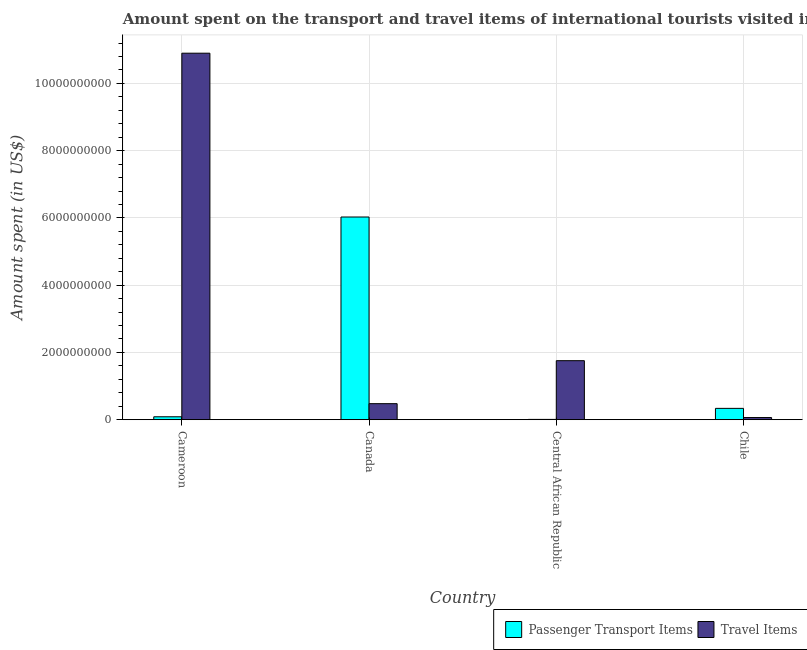How many different coloured bars are there?
Provide a short and direct response. 2. Are the number of bars per tick equal to the number of legend labels?
Provide a succinct answer. Yes. Are the number of bars on each tick of the X-axis equal?
Your answer should be compact. Yes. How many bars are there on the 3rd tick from the right?
Make the answer very short. 2. What is the label of the 1st group of bars from the left?
Keep it short and to the point. Cameroon. In how many cases, is the number of bars for a given country not equal to the number of legend labels?
Provide a short and direct response. 0. What is the amount spent in travel items in Canada?
Your response must be concise. 4.77e+08. Across all countries, what is the maximum amount spent in travel items?
Your answer should be very brief. 1.09e+1. Across all countries, what is the minimum amount spent on passenger transport items?
Your response must be concise. 9.00e+06. In which country was the amount spent on passenger transport items minimum?
Provide a short and direct response. Central African Republic. What is the total amount spent on passenger transport items in the graph?
Ensure brevity in your answer.  6.46e+09. What is the difference between the amount spent in travel items in Cameroon and that in Central African Republic?
Provide a succinct answer. 9.14e+09. What is the difference between the amount spent on passenger transport items in Canada and the amount spent in travel items in Cameroon?
Offer a very short reply. -4.87e+09. What is the average amount spent on passenger transport items per country?
Your response must be concise. 1.62e+09. What is the difference between the amount spent on passenger transport items and amount spent in travel items in Central African Republic?
Offer a terse response. -1.75e+09. In how many countries, is the amount spent in travel items greater than 7200000000 US$?
Make the answer very short. 1. What is the ratio of the amount spent in travel items in Canada to that in Chile?
Your answer should be very brief. 7.45. Is the amount spent on passenger transport items in Cameroon less than that in Chile?
Offer a very short reply. Yes. Is the difference between the amount spent in travel items in Cameroon and Central African Republic greater than the difference between the amount spent on passenger transport items in Cameroon and Central African Republic?
Ensure brevity in your answer.  Yes. What is the difference between the highest and the second highest amount spent on passenger transport items?
Make the answer very short. 5.69e+09. What is the difference between the highest and the lowest amount spent on passenger transport items?
Ensure brevity in your answer.  6.02e+09. Is the sum of the amount spent in travel items in Cameroon and Chile greater than the maximum amount spent on passenger transport items across all countries?
Keep it short and to the point. Yes. What does the 2nd bar from the left in Central African Republic represents?
Provide a short and direct response. Travel Items. What does the 2nd bar from the right in Cameroon represents?
Your answer should be very brief. Passenger Transport Items. What is the difference between two consecutive major ticks on the Y-axis?
Provide a succinct answer. 2.00e+09. Are the values on the major ticks of Y-axis written in scientific E-notation?
Provide a succinct answer. No. Does the graph contain grids?
Ensure brevity in your answer.  Yes. Where does the legend appear in the graph?
Offer a terse response. Bottom right. How many legend labels are there?
Your answer should be compact. 2. How are the legend labels stacked?
Give a very brief answer. Horizontal. What is the title of the graph?
Your answer should be very brief. Amount spent on the transport and travel items of international tourists visited in 2009. What is the label or title of the X-axis?
Provide a short and direct response. Country. What is the label or title of the Y-axis?
Give a very brief answer. Amount spent (in US$). What is the Amount spent (in US$) of Passenger Transport Items in Cameroon?
Give a very brief answer. 8.70e+07. What is the Amount spent (in US$) of Travel Items in Cameroon?
Keep it short and to the point. 1.09e+1. What is the Amount spent (in US$) in Passenger Transport Items in Canada?
Provide a succinct answer. 6.03e+09. What is the Amount spent (in US$) in Travel Items in Canada?
Keep it short and to the point. 4.77e+08. What is the Amount spent (in US$) of Passenger Transport Items in Central African Republic?
Keep it short and to the point. 9.00e+06. What is the Amount spent (in US$) of Travel Items in Central African Republic?
Give a very brief answer. 1.76e+09. What is the Amount spent (in US$) of Passenger Transport Items in Chile?
Ensure brevity in your answer.  3.37e+08. What is the Amount spent (in US$) of Travel Items in Chile?
Your response must be concise. 6.40e+07. Across all countries, what is the maximum Amount spent (in US$) of Passenger Transport Items?
Provide a succinct answer. 6.03e+09. Across all countries, what is the maximum Amount spent (in US$) in Travel Items?
Your answer should be compact. 1.09e+1. Across all countries, what is the minimum Amount spent (in US$) in Passenger Transport Items?
Offer a very short reply. 9.00e+06. Across all countries, what is the minimum Amount spent (in US$) in Travel Items?
Your answer should be compact. 6.40e+07. What is the total Amount spent (in US$) in Passenger Transport Items in the graph?
Provide a succinct answer. 6.46e+09. What is the total Amount spent (in US$) of Travel Items in the graph?
Your answer should be very brief. 1.32e+1. What is the difference between the Amount spent (in US$) in Passenger Transport Items in Cameroon and that in Canada?
Keep it short and to the point. -5.94e+09. What is the difference between the Amount spent (in US$) of Travel Items in Cameroon and that in Canada?
Offer a terse response. 1.04e+1. What is the difference between the Amount spent (in US$) in Passenger Transport Items in Cameroon and that in Central African Republic?
Ensure brevity in your answer.  7.80e+07. What is the difference between the Amount spent (in US$) in Travel Items in Cameroon and that in Central African Republic?
Ensure brevity in your answer.  9.14e+09. What is the difference between the Amount spent (in US$) of Passenger Transport Items in Cameroon and that in Chile?
Ensure brevity in your answer.  -2.50e+08. What is the difference between the Amount spent (in US$) in Travel Items in Cameroon and that in Chile?
Offer a very short reply. 1.08e+1. What is the difference between the Amount spent (in US$) in Passenger Transport Items in Canada and that in Central African Republic?
Offer a very short reply. 6.02e+09. What is the difference between the Amount spent (in US$) of Travel Items in Canada and that in Central African Republic?
Offer a very short reply. -1.28e+09. What is the difference between the Amount spent (in US$) in Passenger Transport Items in Canada and that in Chile?
Offer a very short reply. 5.69e+09. What is the difference between the Amount spent (in US$) of Travel Items in Canada and that in Chile?
Ensure brevity in your answer.  4.13e+08. What is the difference between the Amount spent (in US$) of Passenger Transport Items in Central African Republic and that in Chile?
Your answer should be compact. -3.28e+08. What is the difference between the Amount spent (in US$) in Travel Items in Central African Republic and that in Chile?
Give a very brief answer. 1.69e+09. What is the difference between the Amount spent (in US$) of Passenger Transport Items in Cameroon and the Amount spent (in US$) of Travel Items in Canada?
Offer a terse response. -3.90e+08. What is the difference between the Amount spent (in US$) in Passenger Transport Items in Cameroon and the Amount spent (in US$) in Travel Items in Central African Republic?
Your answer should be compact. -1.67e+09. What is the difference between the Amount spent (in US$) of Passenger Transport Items in Cameroon and the Amount spent (in US$) of Travel Items in Chile?
Your answer should be very brief. 2.30e+07. What is the difference between the Amount spent (in US$) of Passenger Transport Items in Canada and the Amount spent (in US$) of Travel Items in Central African Republic?
Provide a succinct answer. 4.27e+09. What is the difference between the Amount spent (in US$) in Passenger Transport Items in Canada and the Amount spent (in US$) in Travel Items in Chile?
Provide a short and direct response. 5.96e+09. What is the difference between the Amount spent (in US$) of Passenger Transport Items in Central African Republic and the Amount spent (in US$) of Travel Items in Chile?
Offer a very short reply. -5.50e+07. What is the average Amount spent (in US$) of Passenger Transport Items per country?
Keep it short and to the point. 1.62e+09. What is the average Amount spent (in US$) in Travel Items per country?
Provide a succinct answer. 3.30e+09. What is the difference between the Amount spent (in US$) in Passenger Transport Items and Amount spent (in US$) in Travel Items in Cameroon?
Your answer should be compact. -1.08e+1. What is the difference between the Amount spent (in US$) of Passenger Transport Items and Amount spent (in US$) of Travel Items in Canada?
Your answer should be very brief. 5.55e+09. What is the difference between the Amount spent (in US$) of Passenger Transport Items and Amount spent (in US$) of Travel Items in Central African Republic?
Your answer should be compact. -1.75e+09. What is the difference between the Amount spent (in US$) in Passenger Transport Items and Amount spent (in US$) in Travel Items in Chile?
Offer a terse response. 2.73e+08. What is the ratio of the Amount spent (in US$) in Passenger Transport Items in Cameroon to that in Canada?
Provide a short and direct response. 0.01. What is the ratio of the Amount spent (in US$) of Travel Items in Cameroon to that in Canada?
Provide a short and direct response. 22.85. What is the ratio of the Amount spent (in US$) of Passenger Transport Items in Cameroon to that in Central African Republic?
Provide a succinct answer. 9.67. What is the ratio of the Amount spent (in US$) in Travel Items in Cameroon to that in Central African Republic?
Your answer should be very brief. 6.21. What is the ratio of the Amount spent (in US$) of Passenger Transport Items in Cameroon to that in Chile?
Provide a short and direct response. 0.26. What is the ratio of the Amount spent (in US$) in Travel Items in Cameroon to that in Chile?
Your answer should be very brief. 170.28. What is the ratio of the Amount spent (in US$) of Passenger Transport Items in Canada to that in Central African Republic?
Ensure brevity in your answer.  669.67. What is the ratio of the Amount spent (in US$) of Travel Items in Canada to that in Central African Republic?
Make the answer very short. 0.27. What is the ratio of the Amount spent (in US$) in Passenger Transport Items in Canada to that in Chile?
Your answer should be compact. 17.88. What is the ratio of the Amount spent (in US$) in Travel Items in Canada to that in Chile?
Give a very brief answer. 7.45. What is the ratio of the Amount spent (in US$) of Passenger Transport Items in Central African Republic to that in Chile?
Your response must be concise. 0.03. What is the ratio of the Amount spent (in US$) in Travel Items in Central African Republic to that in Chile?
Provide a short and direct response. 27.42. What is the difference between the highest and the second highest Amount spent (in US$) of Passenger Transport Items?
Give a very brief answer. 5.69e+09. What is the difference between the highest and the second highest Amount spent (in US$) of Travel Items?
Give a very brief answer. 9.14e+09. What is the difference between the highest and the lowest Amount spent (in US$) in Passenger Transport Items?
Give a very brief answer. 6.02e+09. What is the difference between the highest and the lowest Amount spent (in US$) in Travel Items?
Keep it short and to the point. 1.08e+1. 